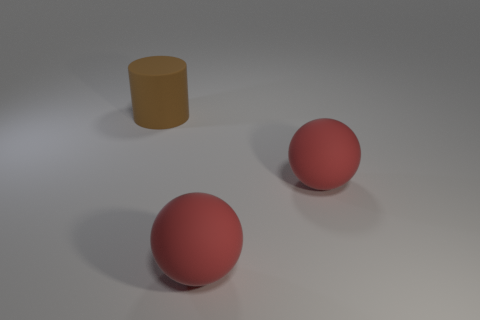What is the material of the big cylinder?
Your response must be concise. Rubber. What number of matte objects are big balls or brown cylinders?
Your answer should be very brief. 3. What is the size of the brown rubber cylinder?
Ensure brevity in your answer.  Large. Is there anything else that has the same material as the brown thing?
Your response must be concise. Yes. What number of other large things have the same shape as the large brown matte thing?
Give a very brief answer. 0. Is the number of brown matte things that are left of the large brown rubber thing greater than the number of big green matte cubes?
Your answer should be very brief. No. What number of matte objects have the same size as the brown cylinder?
Offer a very short reply. 2. How many small objects are either cylinders or red things?
Provide a succinct answer. 0. How many large red things are there?
Offer a very short reply. 2. Are there any big balls behind the big rubber cylinder?
Your answer should be very brief. No. 